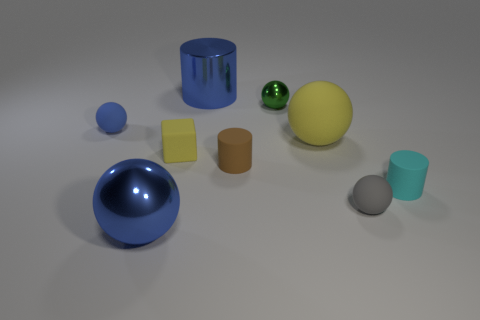Subtract all yellow spheres. How many spheres are left? 4 Subtract all blue metallic spheres. How many spheres are left? 4 Subtract all red spheres. Subtract all gray cylinders. How many spheres are left? 5 Add 1 large purple things. How many objects exist? 10 Subtract all cylinders. How many objects are left? 6 Subtract all small cyan spheres. Subtract all small brown matte things. How many objects are left? 8 Add 4 gray rubber things. How many gray rubber things are left? 5 Add 3 large metallic objects. How many large metallic objects exist? 5 Subtract 0 yellow cylinders. How many objects are left? 9 